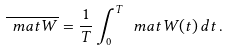Convert formula to latex. <formula><loc_0><loc_0><loc_500><loc_500>\overline { \ m a t W } = \frac { 1 } { T } \int _ { 0 } ^ { T } \ m a t W ( t ) \, d t \, .</formula> 